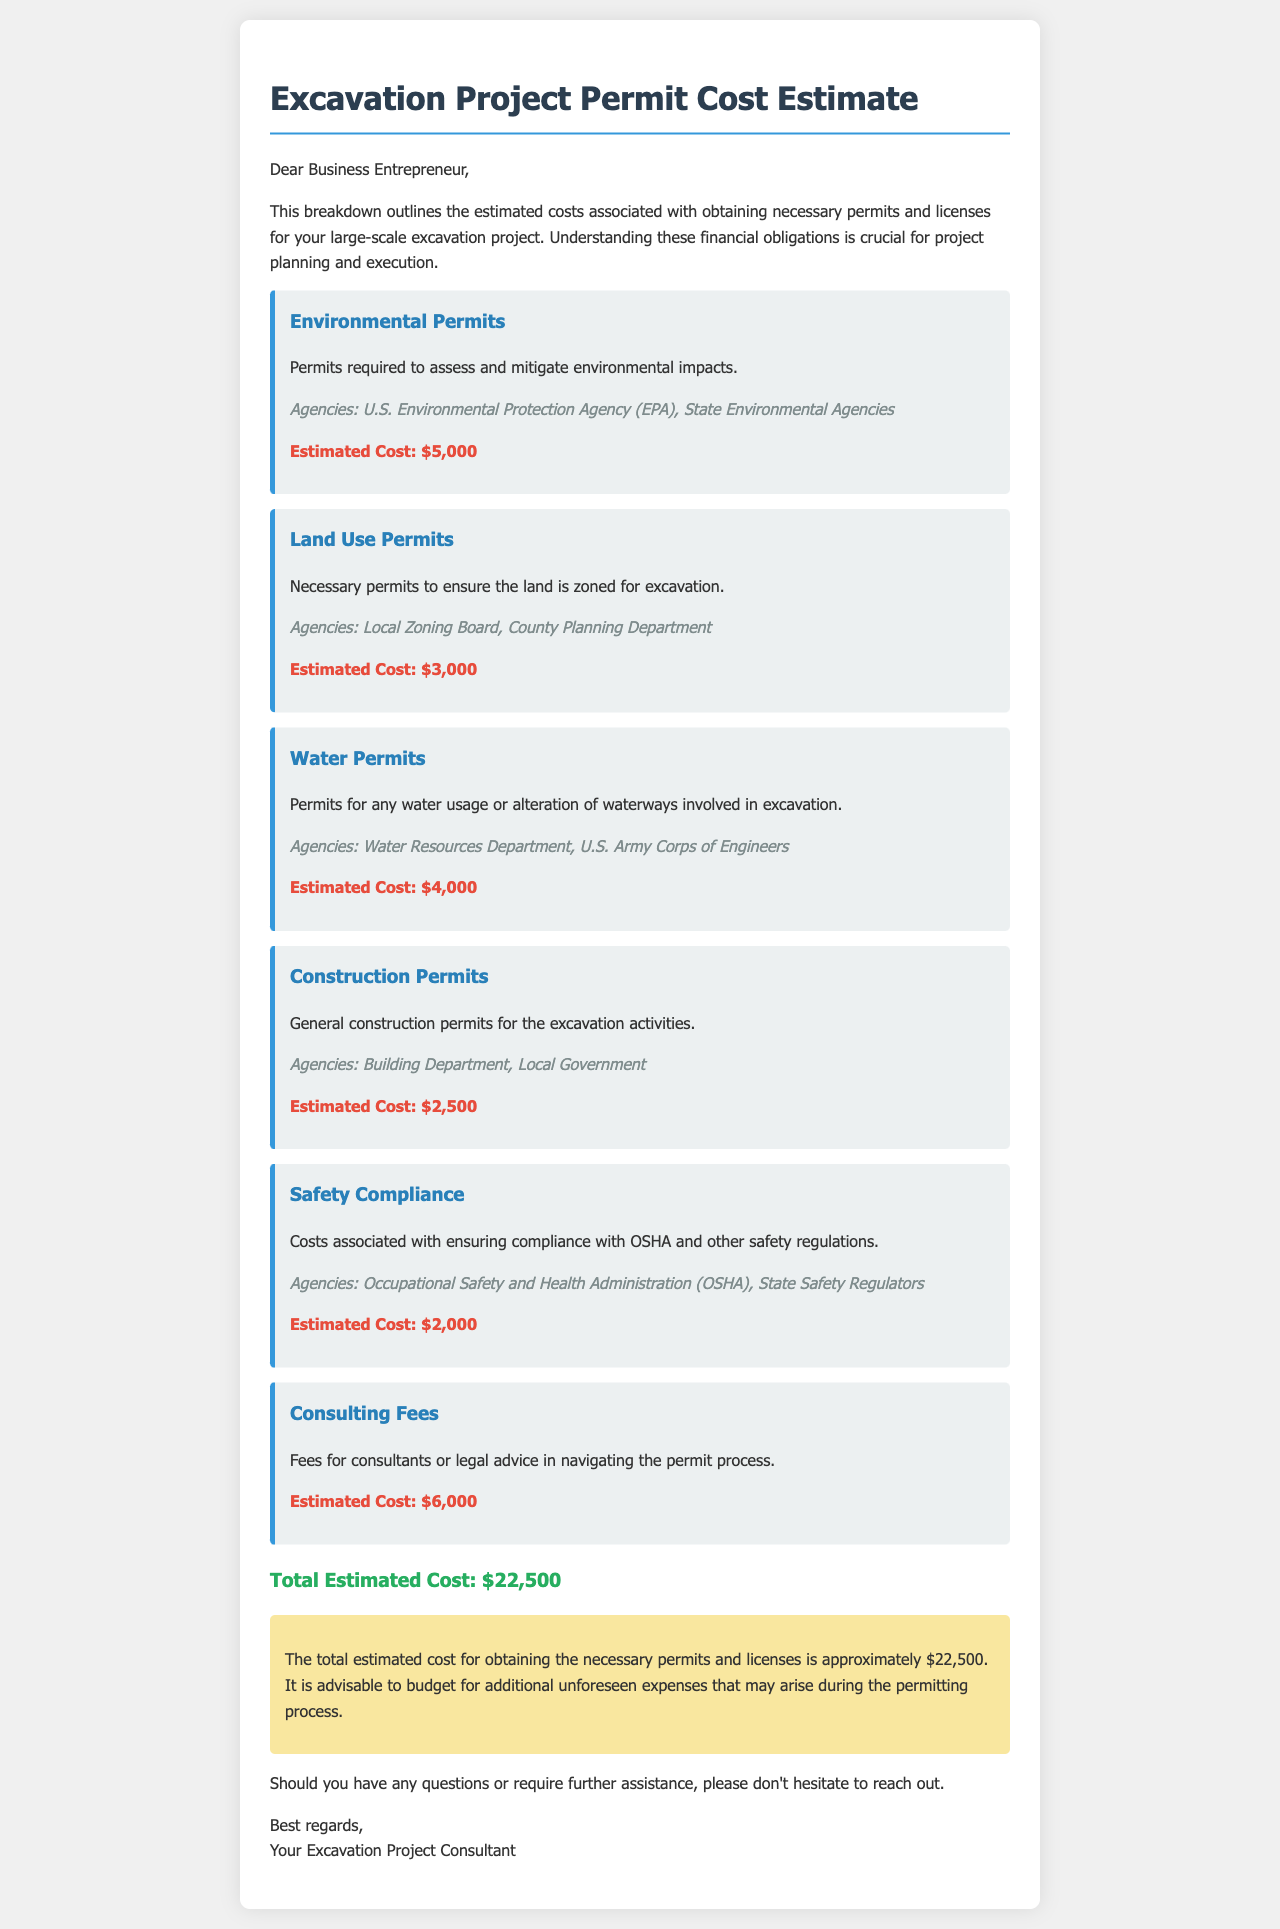What is the total estimated cost? The total estimated cost is clearly stated in the conclusion as $22,500.
Answer: $22,500 What is the estimated cost for Environmental Permits? The estimated cost for Environmental Permits is specifically listed as $5,000 in the cost breakdown section.
Answer: $5,000 Which agencies are involved in obtaining Land Use Permits? The agencies listed for Land Use Permits include the Local Zoning Board and the County Planning Department.
Answer: Local Zoning Board, County Planning Department What is included in the Safety Compliance costs? Safety Compliance costs pertain to ensuring adherence to OSHA and other safety regulations, as indicated in the description.
Answer: OSHA and other safety regulations How much are the Consulting Fees? The document specifies the estimated Consulting Fees as $6,000.
Answer: $6,000 What type of permits are necessary for water usage? Permits for water usage are referred to as Water Permits in the document.
Answer: Water Permits What is the purpose of Construction Permits? The purpose of Construction Permits is to obtain general permits for excavation activities as stated in the cost breakdown.
Answer: General construction permits for excavation activities What should be budgeted for beyond the estimated costs? The conclusion advises budgeting for additional unforeseen expenses that may arise during the permitting process.
Answer: Additional unforeseen expenses 